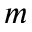<formula> <loc_0><loc_0><loc_500><loc_500>m</formula> 